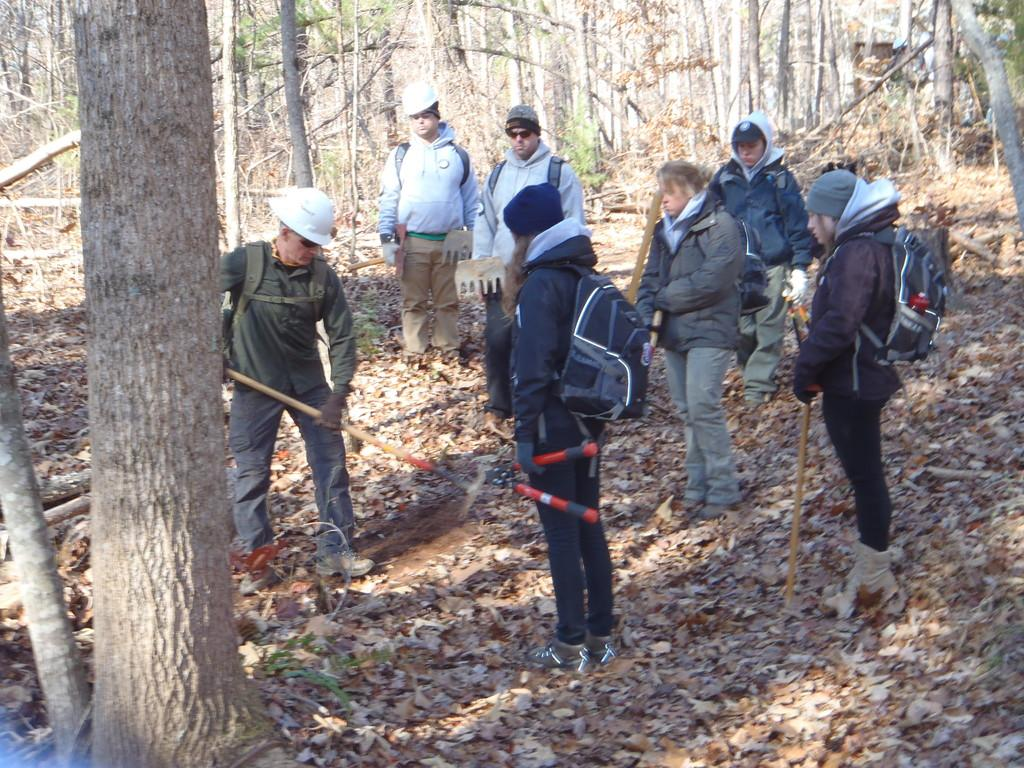How many people are present in the image? There are many people in the image. What are some of the accessories or clothing items that people are wearing? Some people are wearing bags, caps, and jackets. What are some of the activities that people are engaged in? Some people are holding tools. What can be observed on the ground in the image? There are dried leaves on the ground. What type of natural environment is depicted in the image? There are many trees in the image. What type of seed can be seen sprouting from the ground in the image? There is no seed sprouting from the ground in the image; it only shows dried leaves. What joke is being told by the person wearing a cap in the image? There is no joke being told in the image; it only shows people wearing caps and engaging in other activities. 